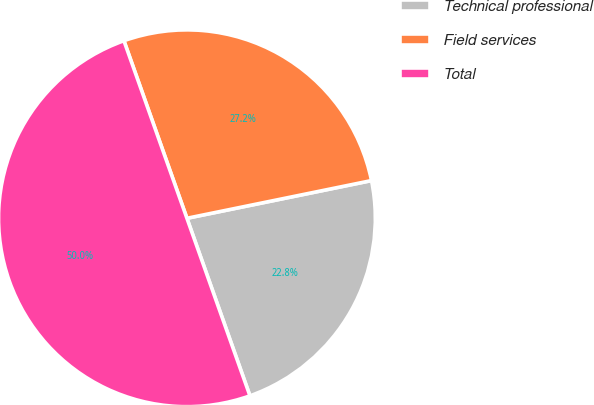Convert chart. <chart><loc_0><loc_0><loc_500><loc_500><pie_chart><fcel>Technical professional<fcel>Field services<fcel>Total<nl><fcel>22.78%<fcel>27.22%<fcel>50.0%<nl></chart> 